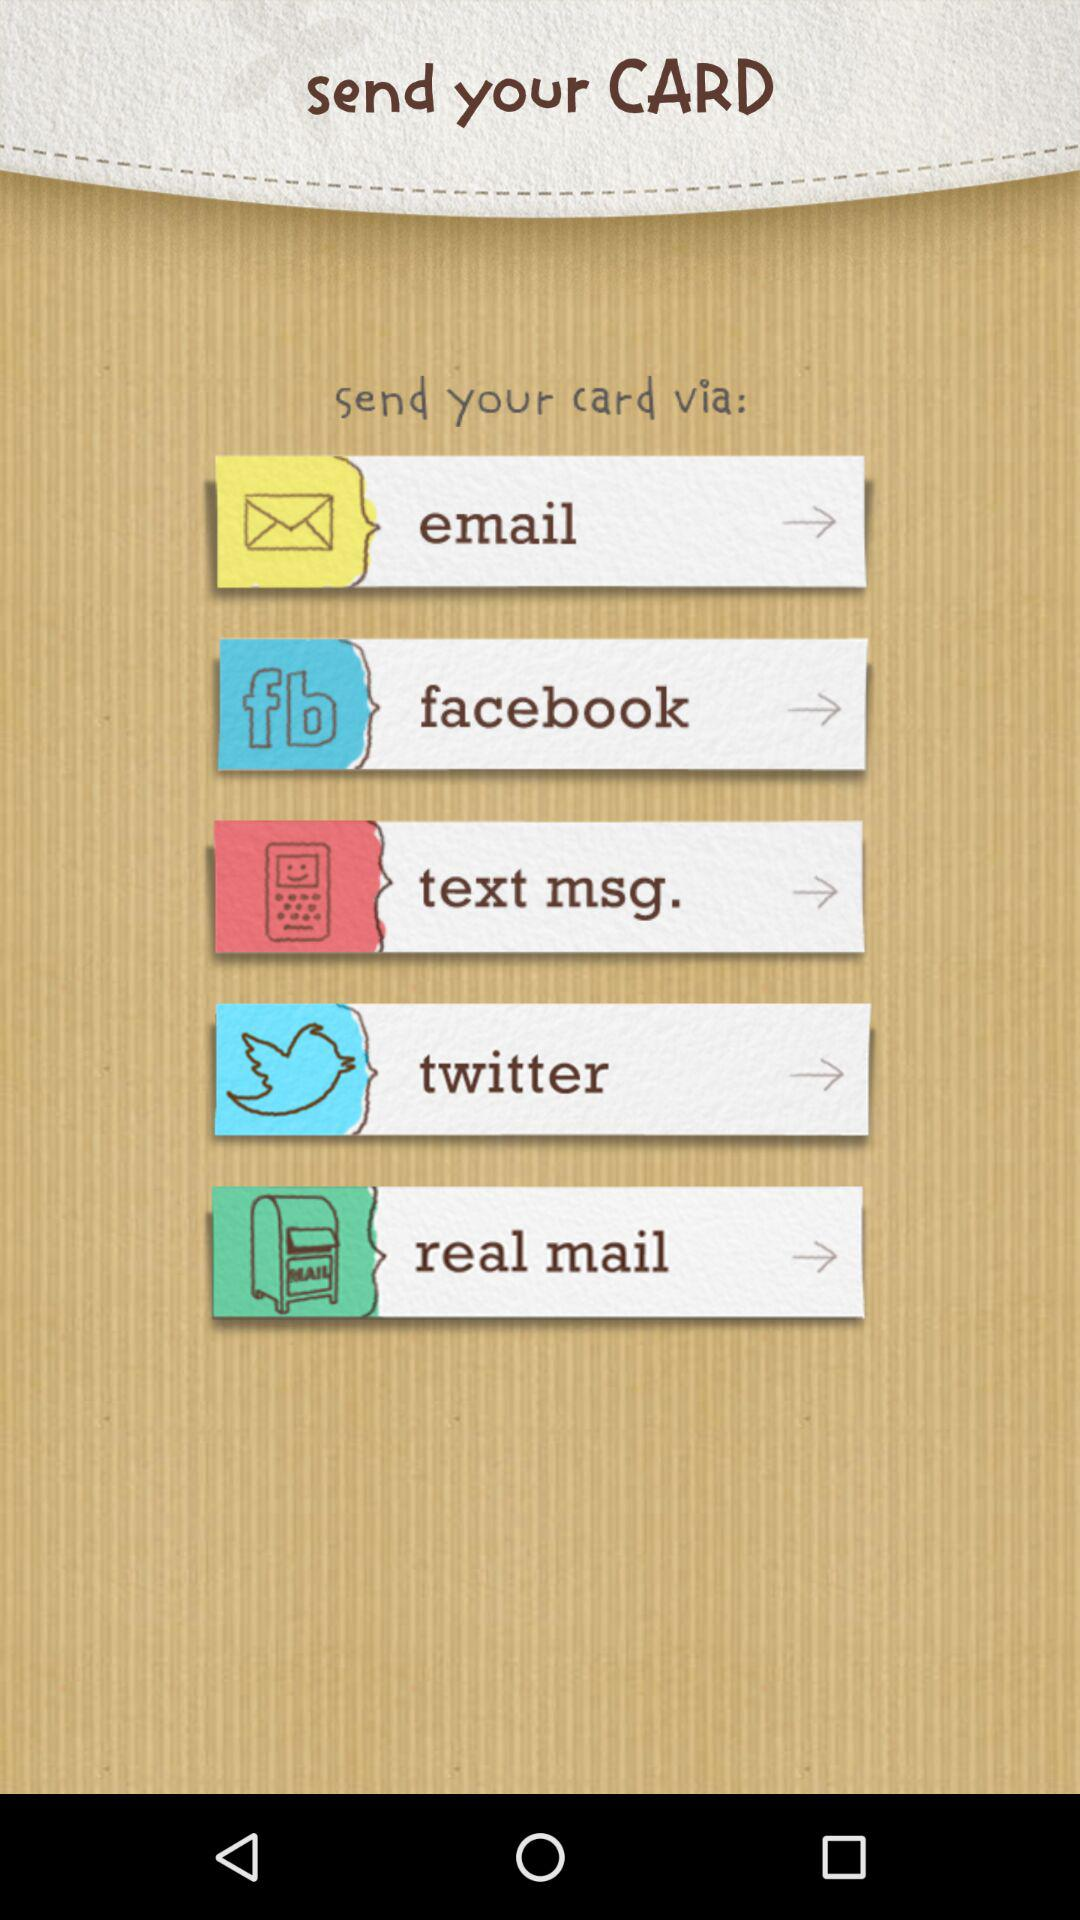Which are the different sending options? The different sending options are "email", "facebook", "text msg.", "twitter" and "real mail". 